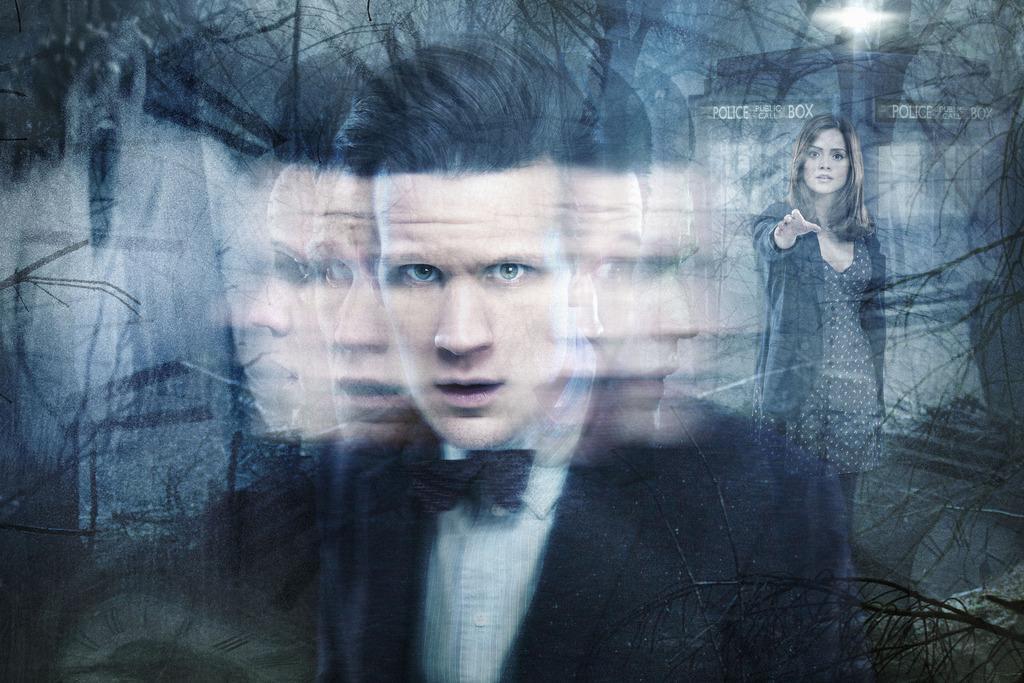Describe this image in one or two sentences. This image is look like a graphic. In the center of the image a man is standing. On the right side of the image a lady is standing. In the background we can see some trees are there. On the right side of the image stairs are present. At the top of the image a light is there. 